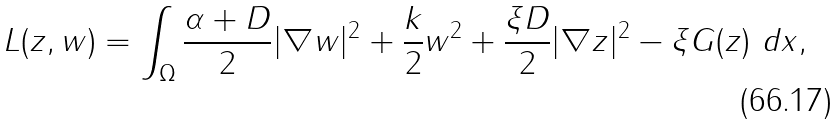<formula> <loc_0><loc_0><loc_500><loc_500>L ( z , w ) = \int _ { \Omega } \frac { \alpha + D } { 2 } | \nabla w | ^ { 2 } + \frac { k } { 2 } w ^ { 2 } + \frac { \xi D } { 2 } | \nabla z | ^ { 2 } - \xi G ( z ) \ d x ,</formula> 